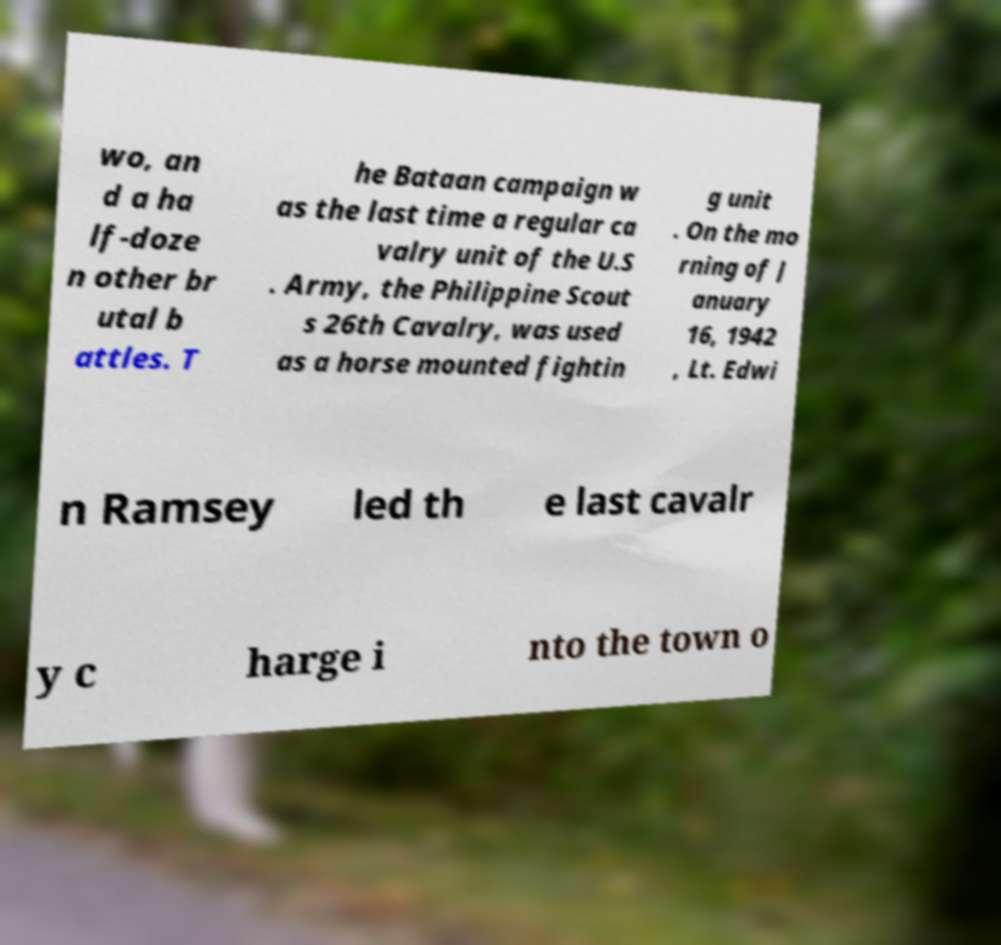Can you accurately transcribe the text from the provided image for me? wo, an d a ha lf-doze n other br utal b attles. T he Bataan campaign w as the last time a regular ca valry unit of the U.S . Army, the Philippine Scout s 26th Cavalry, was used as a horse mounted fightin g unit . On the mo rning of J anuary 16, 1942 , Lt. Edwi n Ramsey led th e last cavalr y c harge i nto the town o 